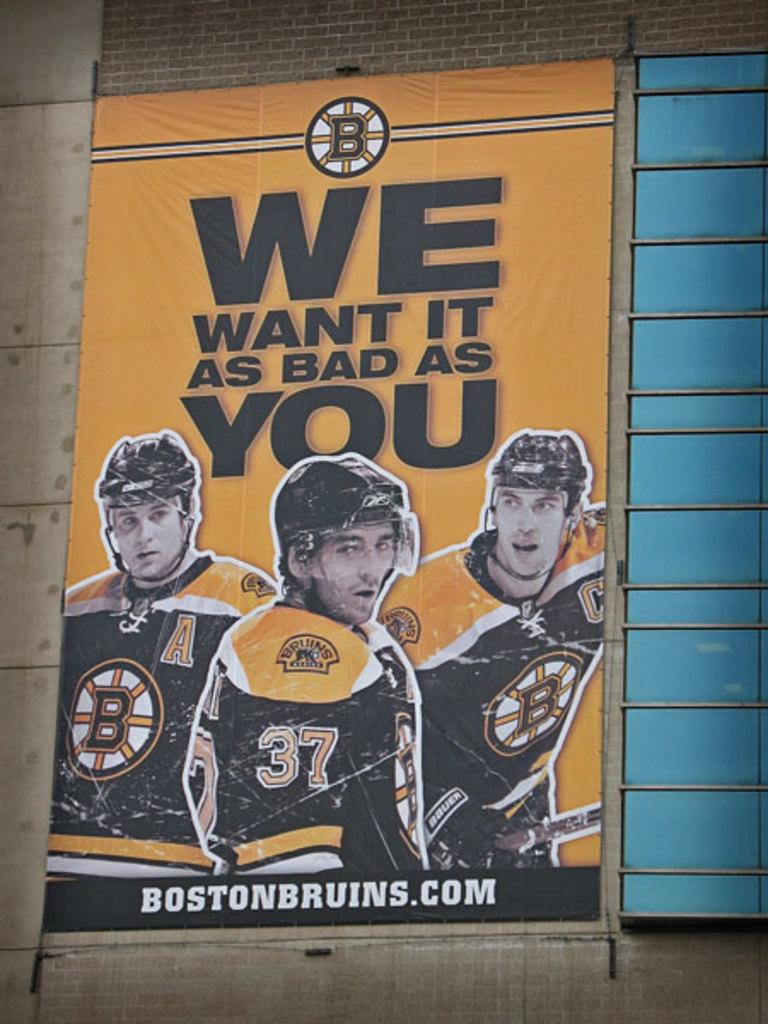<image>
Present a compact description of the photo's key features. Poster showing some hockey players and the words "we want it as bad as you". 